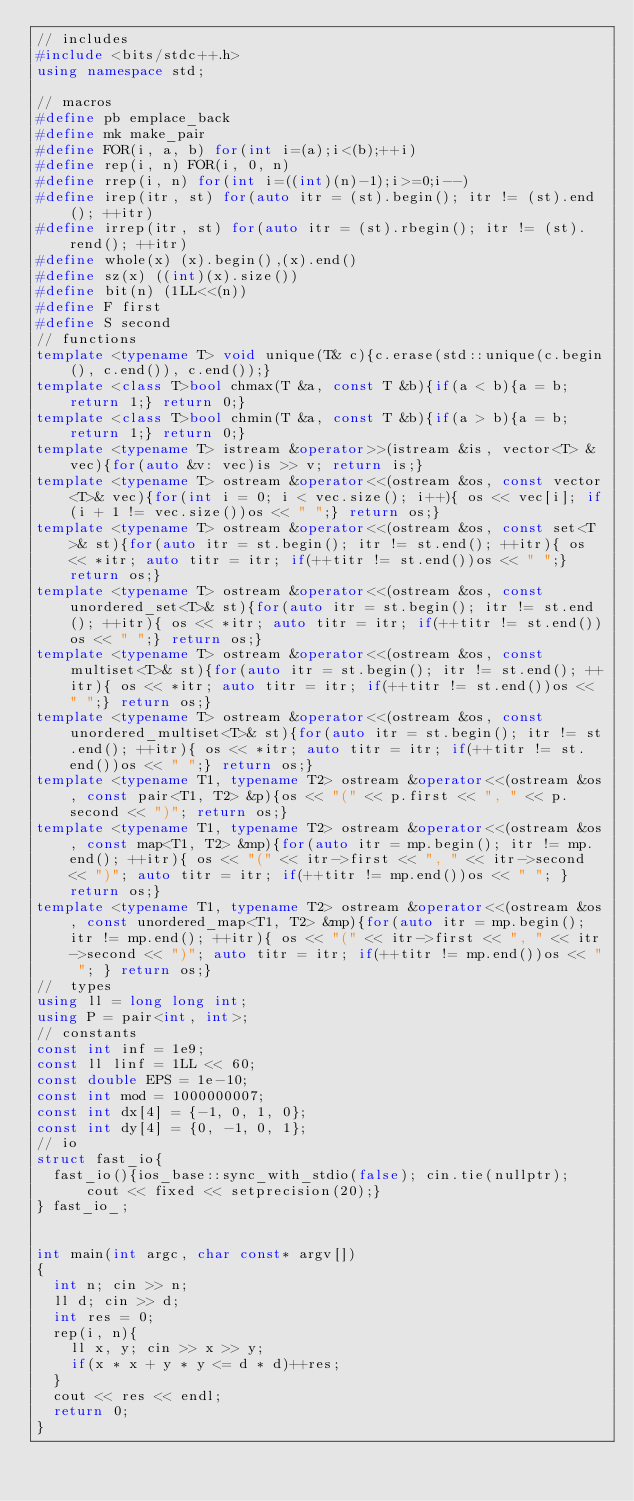<code> <loc_0><loc_0><loc_500><loc_500><_C++_>// includes
#include <bits/stdc++.h>
using namespace std;

// macros
#define pb emplace_back
#define mk make_pair
#define FOR(i, a, b) for(int i=(a);i<(b);++i)
#define rep(i, n) FOR(i, 0, n)
#define rrep(i, n) for(int i=((int)(n)-1);i>=0;i--)
#define irep(itr, st) for(auto itr = (st).begin(); itr != (st).end(); ++itr)
#define irrep(itr, st) for(auto itr = (st).rbegin(); itr != (st).rend(); ++itr)
#define whole(x) (x).begin(),(x).end()
#define sz(x) ((int)(x).size())
#define bit(n) (1LL<<(n))
#define F first
#define S second
// functions
template <typename T> void unique(T& c){c.erase(std::unique(c.begin(), c.end()), c.end());}
template <class T>bool chmax(T &a, const T &b){if(a < b){a = b; return 1;} return 0;}
template <class T>bool chmin(T &a, const T &b){if(a > b){a = b; return 1;} return 0;}
template <typename T> istream &operator>>(istream &is, vector<T> &vec){for(auto &v: vec)is >> v; return is;}
template <typename T> ostream &operator<<(ostream &os, const vector<T>& vec){for(int i = 0; i < vec.size(); i++){ os << vec[i]; if(i + 1 != vec.size())os << " ";} return os;}
template <typename T> ostream &operator<<(ostream &os, const set<T>& st){for(auto itr = st.begin(); itr != st.end(); ++itr){ os << *itr; auto titr = itr; if(++titr != st.end())os << " ";} return os;}
template <typename T> ostream &operator<<(ostream &os, const unordered_set<T>& st){for(auto itr = st.begin(); itr != st.end(); ++itr){ os << *itr; auto titr = itr; if(++titr != st.end())os << " ";} return os;}
template <typename T> ostream &operator<<(ostream &os, const multiset<T>& st){for(auto itr = st.begin(); itr != st.end(); ++itr){ os << *itr; auto titr = itr; if(++titr != st.end())os << " ";} return os;}
template <typename T> ostream &operator<<(ostream &os, const unordered_multiset<T>& st){for(auto itr = st.begin(); itr != st.end(); ++itr){ os << *itr; auto titr = itr; if(++titr != st.end())os << " ";} return os;}
template <typename T1, typename T2> ostream &operator<<(ostream &os, const pair<T1, T2> &p){os << "(" << p.first << ", " << p.second << ")"; return os;}
template <typename T1, typename T2> ostream &operator<<(ostream &os, const map<T1, T2> &mp){for(auto itr = mp.begin(); itr != mp.end(); ++itr){ os << "(" << itr->first << ", " << itr->second << ")"; auto titr = itr; if(++titr != mp.end())os << " "; } return os;}
template <typename T1, typename T2> ostream &operator<<(ostream &os, const unordered_map<T1, T2> &mp){for(auto itr = mp.begin(); itr != mp.end(); ++itr){ os << "(" << itr->first << ", " << itr->second << ")"; auto titr = itr; if(++titr != mp.end())os << " "; } return os;}
//  types
using ll = long long int;
using P = pair<int, int>;
// constants
const int inf = 1e9;
const ll linf = 1LL << 60;
const double EPS = 1e-10;
const int mod = 1000000007;
const int dx[4] = {-1, 0, 1, 0};
const int dy[4] = {0, -1, 0, 1};
// io
struct fast_io{
  fast_io(){ios_base::sync_with_stdio(false); cin.tie(nullptr); cout << fixed << setprecision(20);}
} fast_io_;


int main(int argc, char const* argv[])
{
  int n; cin >> n;
  ll d; cin >> d;
  int res = 0;
  rep(i, n){
    ll x, y; cin >> x >> y;
    if(x * x + y * y <= d * d)++res;
  }
  cout << res << endl;
  return 0;
}
</code> 